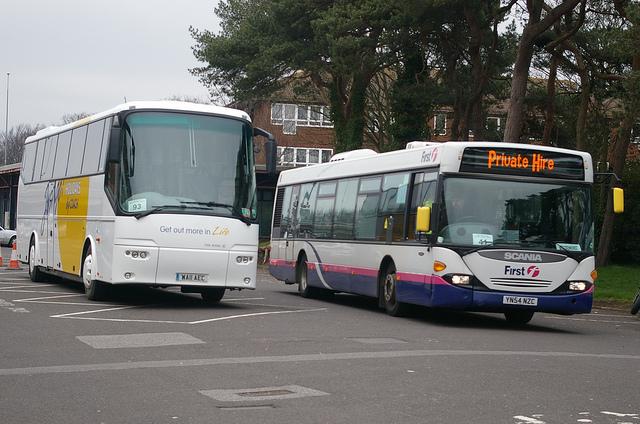How many buses are lined up?
Write a very short answer. 2. Are both buses the same size?
Write a very short answer. No. Are both buses going the same direction?
Short answer required. Yes. Is the left bus for public use right now?
Quick response, please. No. How many busses are there?
Short answer required. 2. How many buses are in a row?
Concise answer only. 2. Are these buses from the US?
Answer briefly. No. What does it say on the top of the bus?
Be succinct. Private hire. Are there arrows?
Concise answer only. No. Are all the vehicles facing the same direction?
Concise answer only. Yes. What football team's uniforms have a similar color scheme to the bus on the right?
Give a very brief answer. Patriots. Is there a person riding a bike in this picture?
Concise answer only. No. What color is the bus on the right?
Be succinct. White. What color is the bus on the left?
Write a very short answer. White. Are all the vehicles going the same way?
Write a very short answer. Yes. Is the driver visible?
Quick response, please. No. Is this the front of the bus?
Short answer required. Yes. 